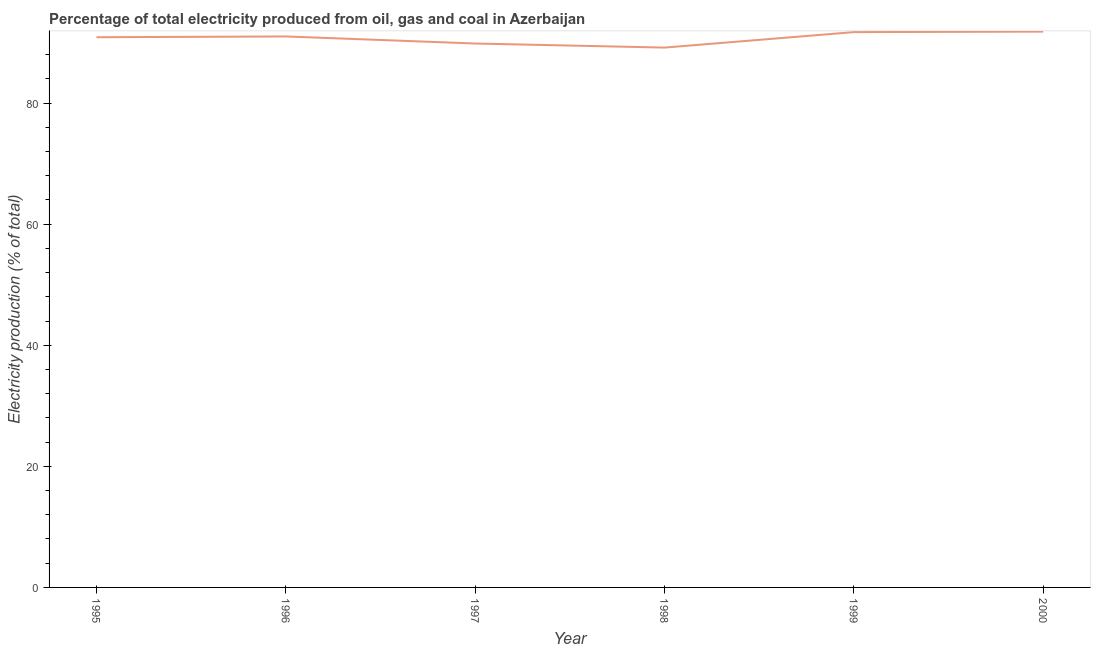What is the electricity production in 1997?
Ensure brevity in your answer.  89.83. Across all years, what is the maximum electricity production?
Provide a succinct answer. 91.8. Across all years, what is the minimum electricity production?
Ensure brevity in your answer.  89.16. In which year was the electricity production maximum?
Offer a terse response. 2000. In which year was the electricity production minimum?
Keep it short and to the point. 1998. What is the sum of the electricity production?
Give a very brief answer. 544.37. What is the difference between the electricity production in 1998 and 2000?
Provide a succinct answer. -2.64. What is the average electricity production per year?
Your response must be concise. 90.73. What is the median electricity production?
Offer a very short reply. 90.93. Do a majority of the years between 1998 and 1997 (inclusive) have electricity production greater than 48 %?
Provide a short and direct response. No. What is the ratio of the electricity production in 1999 to that in 2000?
Ensure brevity in your answer.  1. Is the electricity production in 1996 less than that in 1998?
Offer a very short reply. No. What is the difference between the highest and the second highest electricity production?
Make the answer very short. 0.08. Is the sum of the electricity production in 1995 and 1999 greater than the maximum electricity production across all years?
Ensure brevity in your answer.  Yes. What is the difference between the highest and the lowest electricity production?
Your response must be concise. 2.64. How many lines are there?
Your response must be concise. 1. Are the values on the major ticks of Y-axis written in scientific E-notation?
Make the answer very short. No. Does the graph contain any zero values?
Ensure brevity in your answer.  No. Does the graph contain grids?
Your answer should be very brief. No. What is the title of the graph?
Your answer should be very brief. Percentage of total electricity produced from oil, gas and coal in Azerbaijan. What is the label or title of the X-axis?
Ensure brevity in your answer.  Year. What is the label or title of the Y-axis?
Provide a short and direct response. Electricity production (% of total). What is the Electricity production (% of total) of 1995?
Keep it short and to the point. 90.87. What is the Electricity production (% of total) in 1996?
Ensure brevity in your answer.  91. What is the Electricity production (% of total) of 1997?
Offer a very short reply. 89.83. What is the Electricity production (% of total) in 1998?
Your answer should be compact. 89.16. What is the Electricity production (% of total) in 1999?
Your answer should be compact. 91.71. What is the Electricity production (% of total) in 2000?
Give a very brief answer. 91.8. What is the difference between the Electricity production (% of total) in 1995 and 1996?
Your answer should be very brief. -0.13. What is the difference between the Electricity production (% of total) in 1995 and 1997?
Your response must be concise. 1.04. What is the difference between the Electricity production (% of total) in 1995 and 1998?
Keep it short and to the point. 1.71. What is the difference between the Electricity production (% of total) in 1995 and 1999?
Offer a very short reply. -0.84. What is the difference between the Electricity production (% of total) in 1995 and 2000?
Offer a terse response. -0.93. What is the difference between the Electricity production (% of total) in 1996 and 1997?
Provide a succinct answer. 1.17. What is the difference between the Electricity production (% of total) in 1996 and 1998?
Ensure brevity in your answer.  1.84. What is the difference between the Electricity production (% of total) in 1996 and 1999?
Your answer should be compact. -0.72. What is the difference between the Electricity production (% of total) in 1996 and 2000?
Ensure brevity in your answer.  -0.8. What is the difference between the Electricity production (% of total) in 1997 and 1998?
Your answer should be compact. 0.67. What is the difference between the Electricity production (% of total) in 1997 and 1999?
Provide a short and direct response. -1.88. What is the difference between the Electricity production (% of total) in 1997 and 2000?
Your response must be concise. -1.97. What is the difference between the Electricity production (% of total) in 1998 and 1999?
Your answer should be very brief. -2.55. What is the difference between the Electricity production (% of total) in 1998 and 2000?
Provide a short and direct response. -2.64. What is the difference between the Electricity production (% of total) in 1999 and 2000?
Ensure brevity in your answer.  -0.08. What is the ratio of the Electricity production (% of total) in 1995 to that in 1996?
Ensure brevity in your answer.  1. What is the ratio of the Electricity production (% of total) in 1995 to that in 2000?
Keep it short and to the point. 0.99. What is the ratio of the Electricity production (% of total) in 1996 to that in 1997?
Provide a short and direct response. 1.01. What is the ratio of the Electricity production (% of total) in 1996 to that in 1998?
Provide a short and direct response. 1.02. What is the ratio of the Electricity production (% of total) in 1997 to that in 1998?
Provide a succinct answer. 1.01. What is the ratio of the Electricity production (% of total) in 1998 to that in 1999?
Offer a very short reply. 0.97. What is the ratio of the Electricity production (% of total) in 1998 to that in 2000?
Offer a very short reply. 0.97. What is the ratio of the Electricity production (% of total) in 1999 to that in 2000?
Your response must be concise. 1. 